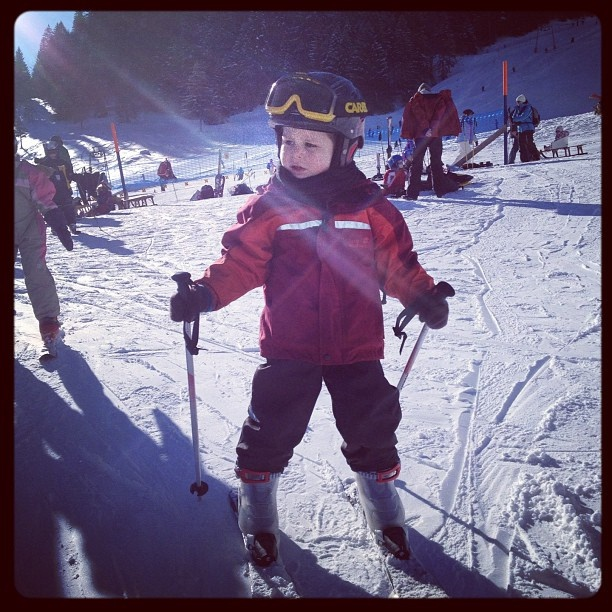Describe the objects in this image and their specific colors. I can see people in black and purple tones, people in black, purple, and gray tones, people in black and purple tones, skis in black, navy, gray, and darkgray tones, and people in black, navy, and purple tones in this image. 